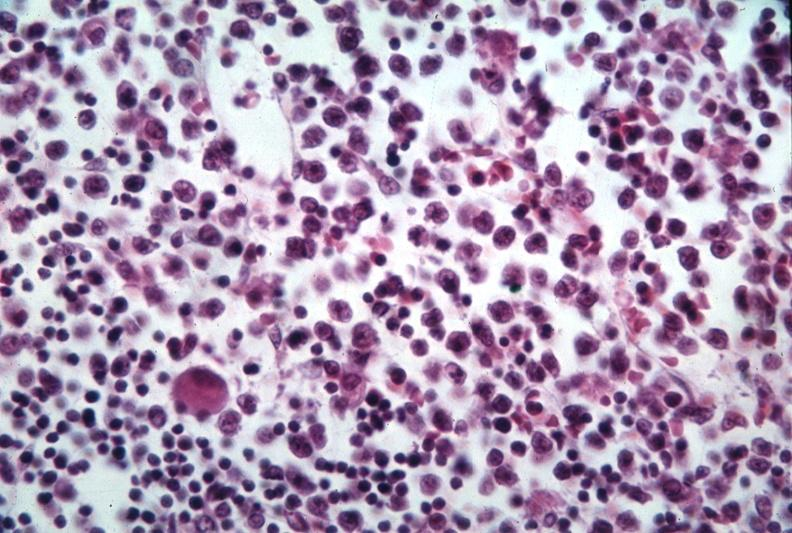what is present?
Answer the question using a single word or phrase. Lymphoblastic lymphoma 